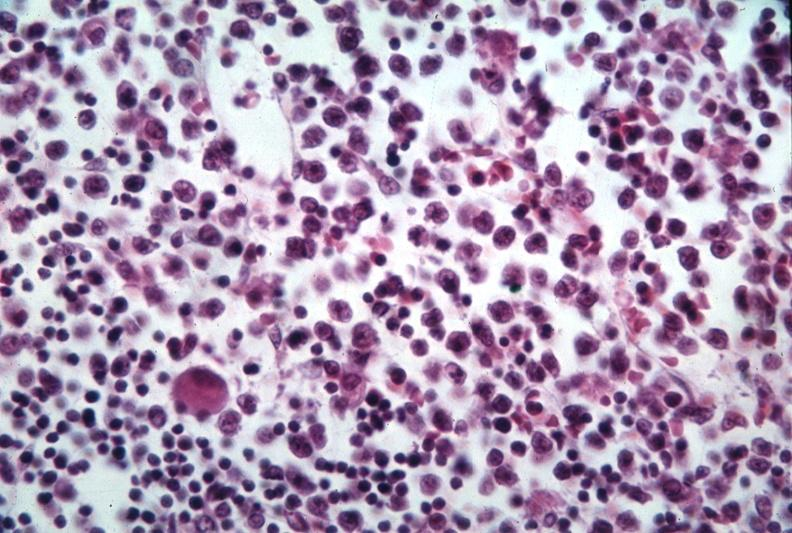what is present?
Answer the question using a single word or phrase. Lymphoblastic lymphoma 